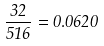<formula> <loc_0><loc_0><loc_500><loc_500>\frac { 3 2 } { 5 1 6 } = 0 . 0 6 2 0</formula> 